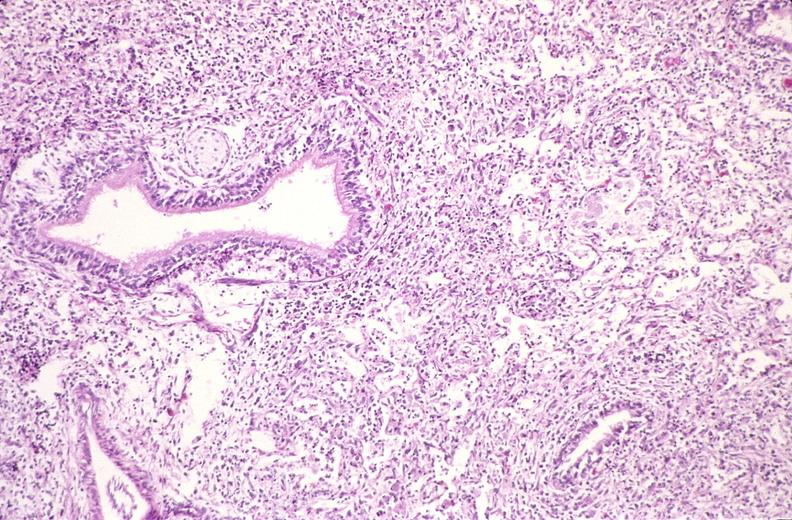what does this image show?
Answer the question using a single word or phrase. Lung 